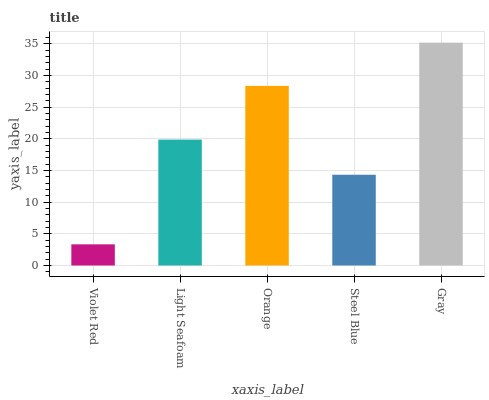Is Violet Red the minimum?
Answer yes or no. Yes. Is Gray the maximum?
Answer yes or no. Yes. Is Light Seafoam the minimum?
Answer yes or no. No. Is Light Seafoam the maximum?
Answer yes or no. No. Is Light Seafoam greater than Violet Red?
Answer yes or no. Yes. Is Violet Red less than Light Seafoam?
Answer yes or no. Yes. Is Violet Red greater than Light Seafoam?
Answer yes or no. No. Is Light Seafoam less than Violet Red?
Answer yes or no. No. Is Light Seafoam the high median?
Answer yes or no. Yes. Is Light Seafoam the low median?
Answer yes or no. Yes. Is Violet Red the high median?
Answer yes or no. No. Is Gray the low median?
Answer yes or no. No. 